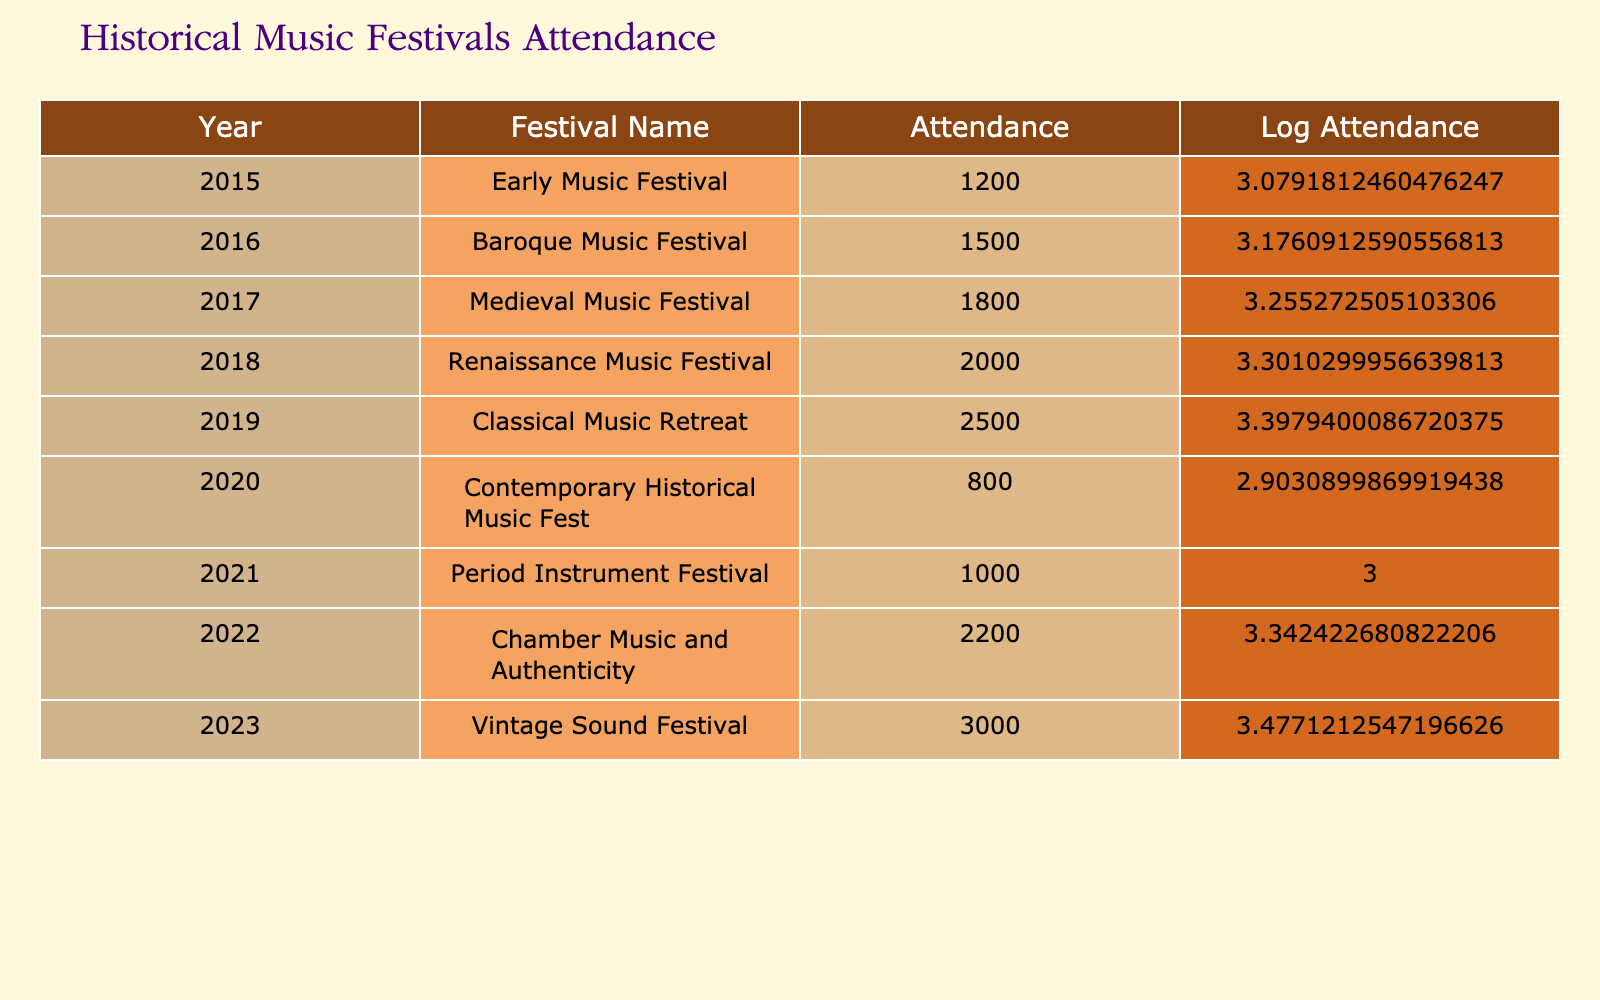What was the attendance at the Renaissance Music Festival in 2018? The table indicates that the attendance for the Renaissance Music Festival in the year 2018 is listed directly under the Attendance column next to the corresponding year. That value is 2000.
Answer: 2000 What year had the highest attendance and what was that number? Looking through the Attendance column, I can see that the highest attendance figure is 3000, which corresponds to the Vintage Sound Festival in the year 2023.
Answer: 2023, 3000 What is the average attendance of the music festivals from 2015 to 2023? To find the average, we sum all the attendance figures: 1200 + 1500 + 1800 + 2000 + 2500 + 800 + 1000 + 2200 + 3000 = 15500. There are 9 data points, so the average is 15500 divided by 9, which equals approximately 1722.22.
Answer: 1722.22 Did the attendance at the Contemporary Historical Music Fest in 2020 exceed the attendance of the Baroque Music Festival in 2016? The attendance for the Contemporary Historical Music Fest in 2020 is 800, whereas the attendance for the Baroque Music Festival in 2016 is listed as 1500. Since 800 is less than 1500, the answer is no.
Answer: No How much did the attendance increase from the Early Music Festival in 2015 to the Vintage Sound Festival in 2023? The attendance in 2015 was 1200 and in 2023 it was 3000. To find the increase, we subtract: 3000 - 1200 = 1800. Therefore, the attendance increased by 1800.
Answer: 1800 Was there a decline in attendance from the Classical Music Retreat in 2019 to the Period Instrument Festival in 2021? The attendance for the Classical Music Retreat in 2019 was 2500, while the Period Instrument Festival in 2021 had an attendance of 1000. Since 1000 is less than 2500, it verifies that there was indeed a decline.
Answer: Yes What is the difference in attendance between the Medieval Music Festival in 2017 and the Renaissance Music Festival in 2018? The attendance for the Medieval Music Festival in 2017 was 1800, and for the Renaissance Music Festival in 2018, it was 2000. The difference is calculated by subtracting: 2000 - 1800 = 200.
Answer: 200 Which festival had the lowest attendance and what year was it held? From the Attendance column, the lowest attendance figure is 800 for the Contemporary Historical Music Fest in 2020. This information is confirmed by checking all attendance numbers.
Answer: 2020, 800 